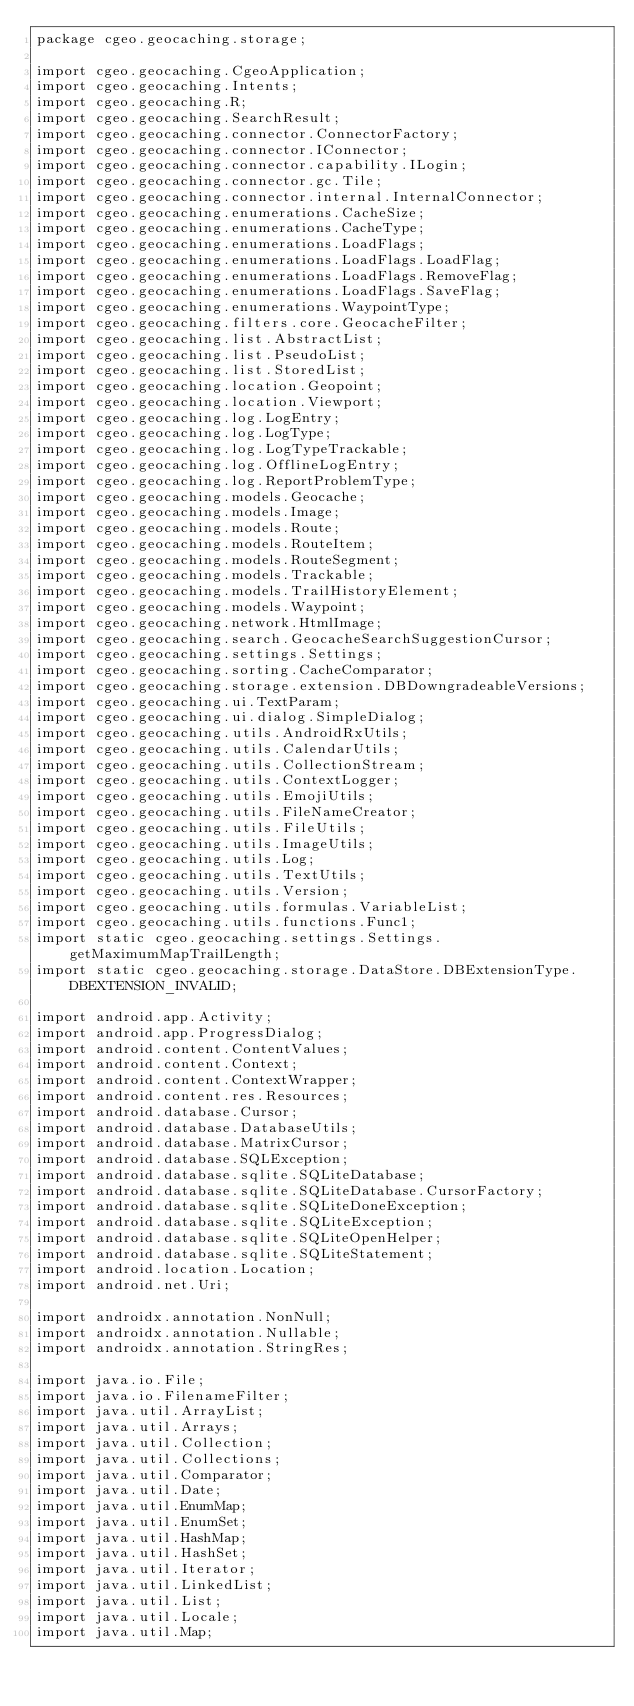<code> <loc_0><loc_0><loc_500><loc_500><_Java_>package cgeo.geocaching.storage;

import cgeo.geocaching.CgeoApplication;
import cgeo.geocaching.Intents;
import cgeo.geocaching.R;
import cgeo.geocaching.SearchResult;
import cgeo.geocaching.connector.ConnectorFactory;
import cgeo.geocaching.connector.IConnector;
import cgeo.geocaching.connector.capability.ILogin;
import cgeo.geocaching.connector.gc.Tile;
import cgeo.geocaching.connector.internal.InternalConnector;
import cgeo.geocaching.enumerations.CacheSize;
import cgeo.geocaching.enumerations.CacheType;
import cgeo.geocaching.enumerations.LoadFlags;
import cgeo.geocaching.enumerations.LoadFlags.LoadFlag;
import cgeo.geocaching.enumerations.LoadFlags.RemoveFlag;
import cgeo.geocaching.enumerations.LoadFlags.SaveFlag;
import cgeo.geocaching.enumerations.WaypointType;
import cgeo.geocaching.filters.core.GeocacheFilter;
import cgeo.geocaching.list.AbstractList;
import cgeo.geocaching.list.PseudoList;
import cgeo.geocaching.list.StoredList;
import cgeo.geocaching.location.Geopoint;
import cgeo.geocaching.location.Viewport;
import cgeo.geocaching.log.LogEntry;
import cgeo.geocaching.log.LogType;
import cgeo.geocaching.log.LogTypeTrackable;
import cgeo.geocaching.log.OfflineLogEntry;
import cgeo.geocaching.log.ReportProblemType;
import cgeo.geocaching.models.Geocache;
import cgeo.geocaching.models.Image;
import cgeo.geocaching.models.Route;
import cgeo.geocaching.models.RouteItem;
import cgeo.geocaching.models.RouteSegment;
import cgeo.geocaching.models.Trackable;
import cgeo.geocaching.models.TrailHistoryElement;
import cgeo.geocaching.models.Waypoint;
import cgeo.geocaching.network.HtmlImage;
import cgeo.geocaching.search.GeocacheSearchSuggestionCursor;
import cgeo.geocaching.settings.Settings;
import cgeo.geocaching.sorting.CacheComparator;
import cgeo.geocaching.storage.extension.DBDowngradeableVersions;
import cgeo.geocaching.ui.TextParam;
import cgeo.geocaching.ui.dialog.SimpleDialog;
import cgeo.geocaching.utils.AndroidRxUtils;
import cgeo.geocaching.utils.CalendarUtils;
import cgeo.geocaching.utils.CollectionStream;
import cgeo.geocaching.utils.ContextLogger;
import cgeo.geocaching.utils.EmojiUtils;
import cgeo.geocaching.utils.FileNameCreator;
import cgeo.geocaching.utils.FileUtils;
import cgeo.geocaching.utils.ImageUtils;
import cgeo.geocaching.utils.Log;
import cgeo.geocaching.utils.TextUtils;
import cgeo.geocaching.utils.Version;
import cgeo.geocaching.utils.formulas.VariableList;
import cgeo.geocaching.utils.functions.Func1;
import static cgeo.geocaching.settings.Settings.getMaximumMapTrailLength;
import static cgeo.geocaching.storage.DataStore.DBExtensionType.DBEXTENSION_INVALID;

import android.app.Activity;
import android.app.ProgressDialog;
import android.content.ContentValues;
import android.content.Context;
import android.content.ContextWrapper;
import android.content.res.Resources;
import android.database.Cursor;
import android.database.DatabaseUtils;
import android.database.MatrixCursor;
import android.database.SQLException;
import android.database.sqlite.SQLiteDatabase;
import android.database.sqlite.SQLiteDatabase.CursorFactory;
import android.database.sqlite.SQLiteDoneException;
import android.database.sqlite.SQLiteException;
import android.database.sqlite.SQLiteOpenHelper;
import android.database.sqlite.SQLiteStatement;
import android.location.Location;
import android.net.Uri;

import androidx.annotation.NonNull;
import androidx.annotation.Nullable;
import androidx.annotation.StringRes;

import java.io.File;
import java.io.FilenameFilter;
import java.util.ArrayList;
import java.util.Arrays;
import java.util.Collection;
import java.util.Collections;
import java.util.Comparator;
import java.util.Date;
import java.util.EnumMap;
import java.util.EnumSet;
import java.util.HashMap;
import java.util.HashSet;
import java.util.Iterator;
import java.util.LinkedList;
import java.util.List;
import java.util.Locale;
import java.util.Map;</code> 